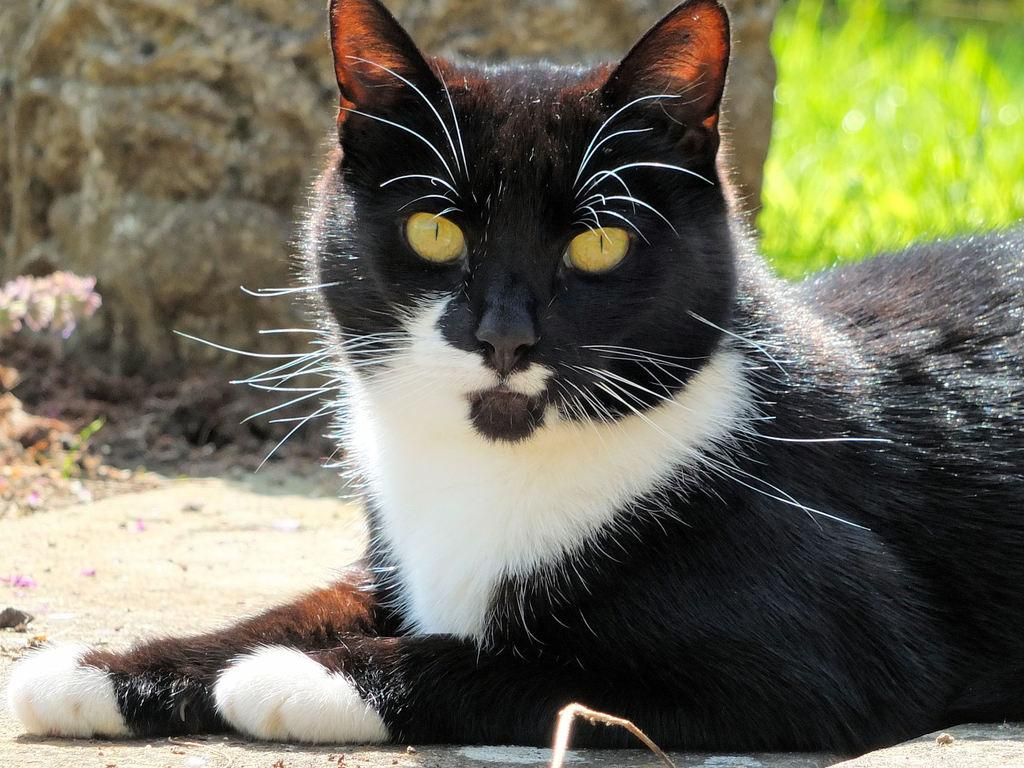What type of animal is present in the image? There is a cat in the picture. Where are the plants located in the image? The plants are in the top right hand side of the image. What can be seen in the background of the image? There appears to be a stone in the background of the image. What type of footwear is the cat wearing in the image? There is no footwear present in the image, as cats do not wear shoes. 